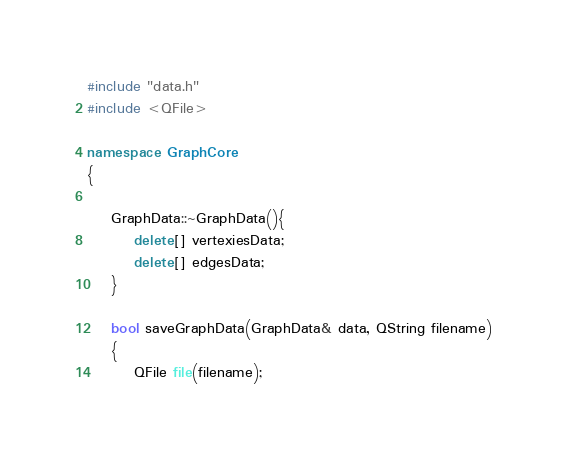<code> <loc_0><loc_0><loc_500><loc_500><_C++_>#include "data.h"
#include <QFile>

namespace GraphCore
{

    GraphData::~GraphData(){
        delete[] vertexiesData;
        delete[] edgesData;
    }

    bool saveGraphData(GraphData& data, QString filename)
    {
        QFile file(filename);</code> 